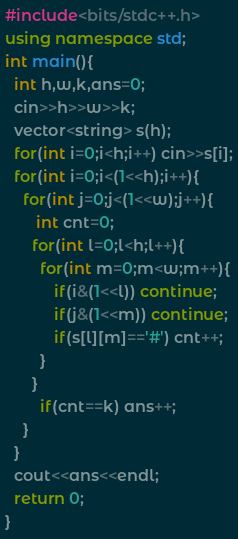Convert code to text. <code><loc_0><loc_0><loc_500><loc_500><_C++_>#include<bits/stdc++.h>
using namespace std;
int main(){
  int h,w,k,ans=0;
  cin>>h>>w>>k;
  vector<string> s(h);
  for(int i=0;i<h;i++) cin>>s[i];
  for(int i=0;i<(1<<h);i++){
    for(int j=0;j<(1<<w);j++){
       int cnt=0;
      for(int l=0;l<h;l++){
        for(int m=0;m<w;m++){
           if(i&(1<<l)) continue;
           if(j&(1<<m)) continue;
           if(s[l][m]=='#') cnt++;
        }
      }
        if(cnt==k) ans++;
    }
  }
  cout<<ans<<endl;
  return 0;
}
</code> 